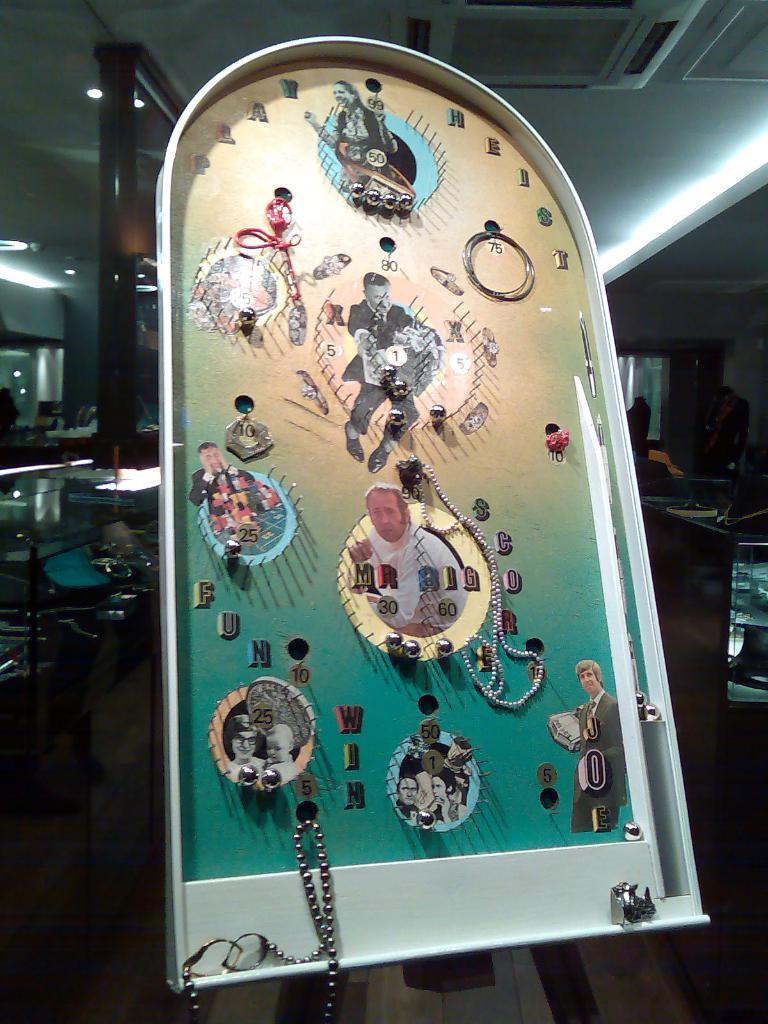Describe this image in one or two sentences. In this picture we can see a game board in the middle. There is a central ac. This is the floor and there is a table. And this is the light. 